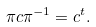Convert formula to latex. <formula><loc_0><loc_0><loc_500><loc_500>\pi c \pi ^ { - 1 } = c ^ { t } .</formula> 